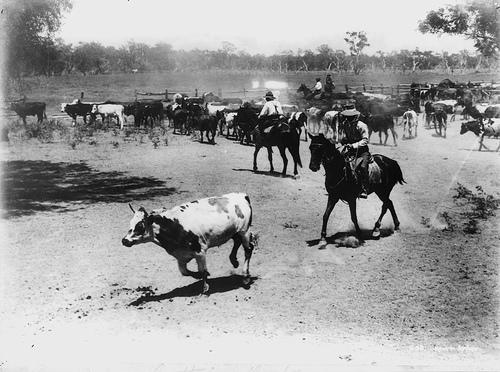When was the photo taken?
Concise answer only. 1900. How many horses are in the photo?
Short answer required. 4. How many cows are there?
Be succinct. 20. What colors are the horses?
Write a very short answer. Black. Is the ground wet?
Concise answer only. No. What color are the horses?
Quick response, please. Black. Are the cattle fenced?
Give a very brief answer. Yes. Do the cows have spots?
Be succinct. Yes. How many horses are there?
Quick response, please. 4. 